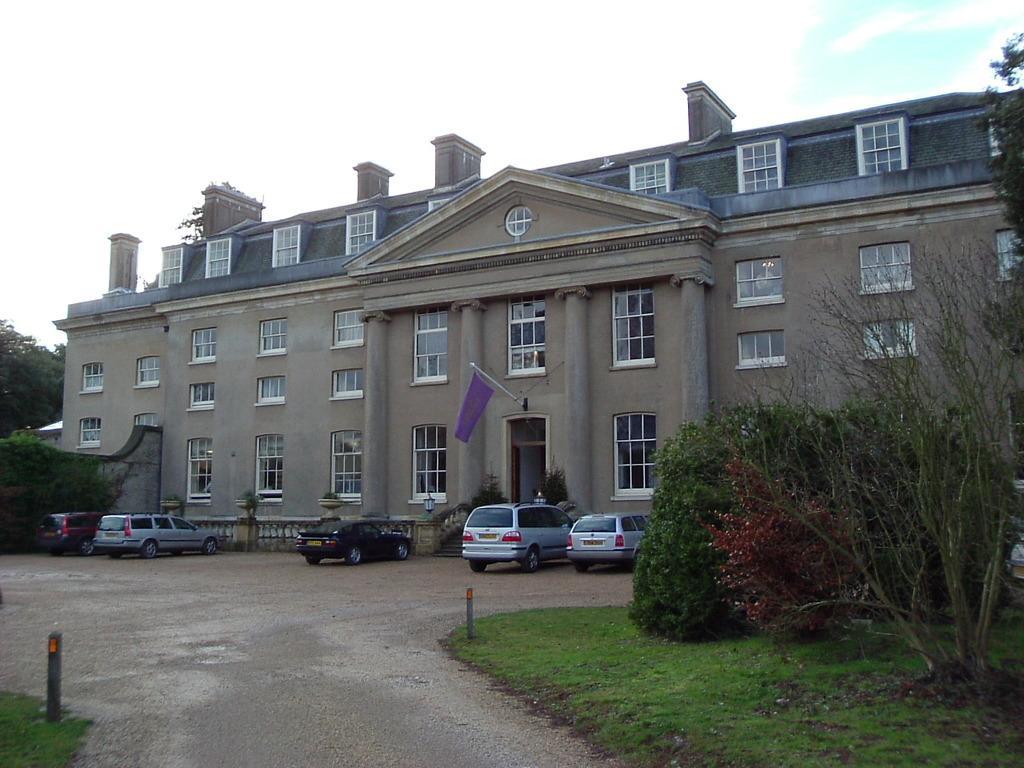How would you summarize this image in a sentence or two? In this image there is a building in the middle. To the building there is a flag. In front of the building there are few cars parked on the road. On the right side there are plants. At the top there is the sky. In the middle there is a way. There are two poles on either side of the way. 